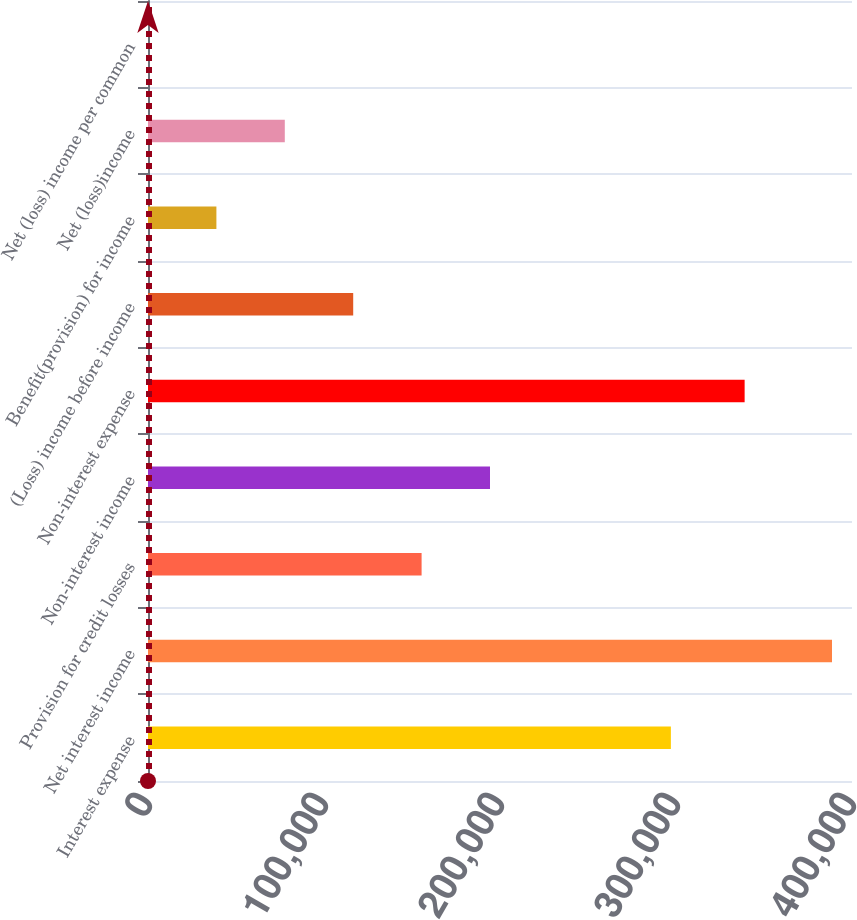Convert chart. <chart><loc_0><loc_0><loc_500><loc_500><bar_chart><fcel>Interest expense<fcel>Net interest income<fcel>Provision for credit losses<fcel>Non-interest income<fcel>Non-interest expense<fcel>(Loss) income before income<fcel>Benefit(provision) for income<fcel>Net (loss)income<fcel>Net (loss) income per common<nl><fcel>297092<fcel>388636<fcel>155454<fcel>194318<fcel>338996<fcel>116591<fcel>38863.8<fcel>77727.3<fcel>0.17<nl></chart> 